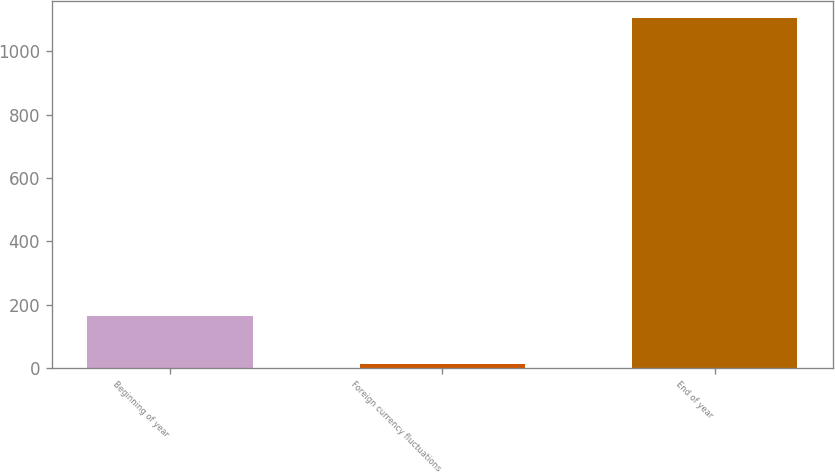Convert chart to OTSL. <chart><loc_0><loc_0><loc_500><loc_500><bar_chart><fcel>Beginning of year<fcel>Foreign currency fluctuations<fcel>End of year<nl><fcel>163.1<fcel>12.3<fcel>1104.7<nl></chart> 